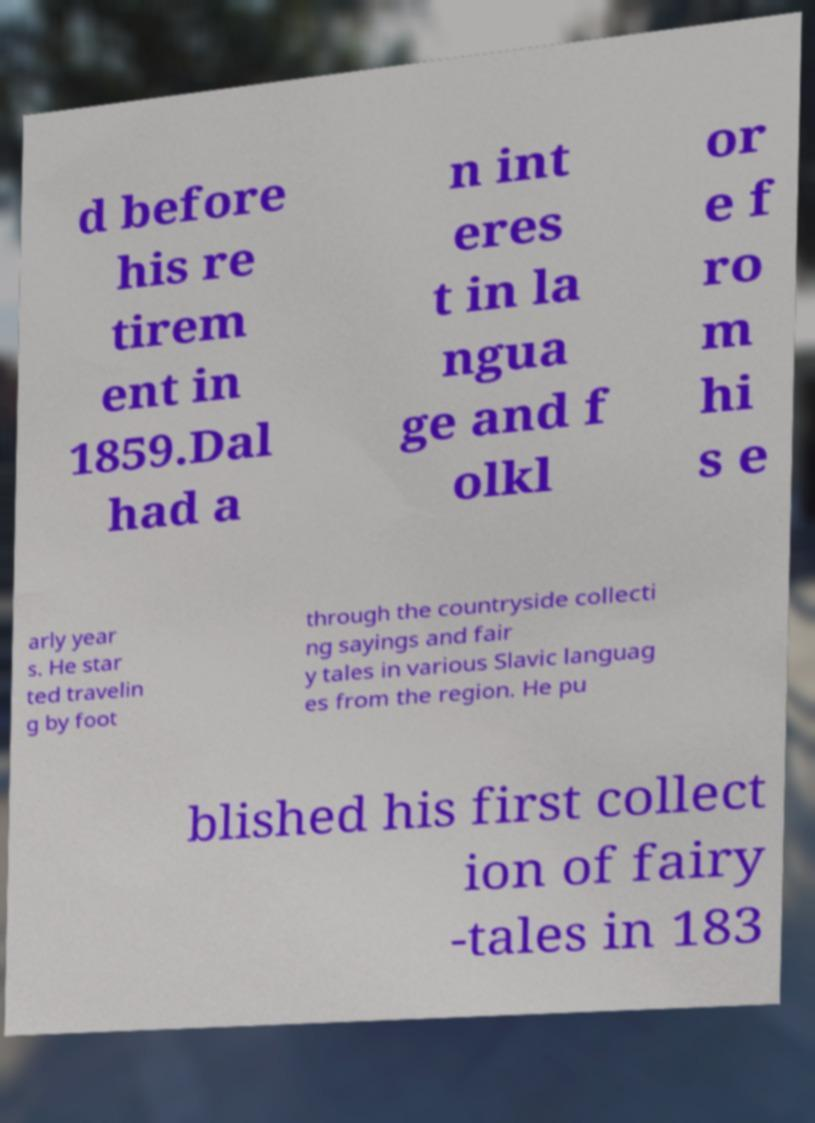Could you assist in decoding the text presented in this image and type it out clearly? d before his re tirem ent in 1859.Dal had a n int eres t in la ngua ge and f olkl or e f ro m hi s e arly year s. He star ted travelin g by foot through the countryside collecti ng sayings and fair y tales in various Slavic languag es from the region. He pu blished his first collect ion of fairy -tales in 183 